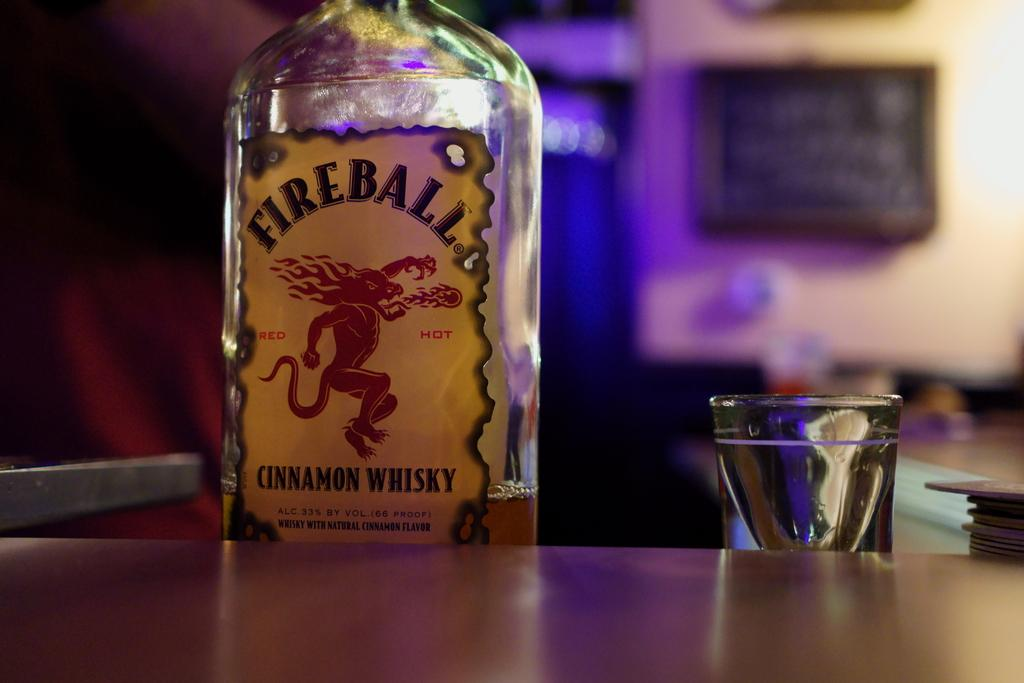What is one object visible in the image? There is a bottle in the image. What is another object visible in the image? There is a glass in the image. What type of food is being prepared in the image? There is no food visible in the image; only a bottle and a glass are present. Can you see a rat in the image? There is no rat present in the image. 